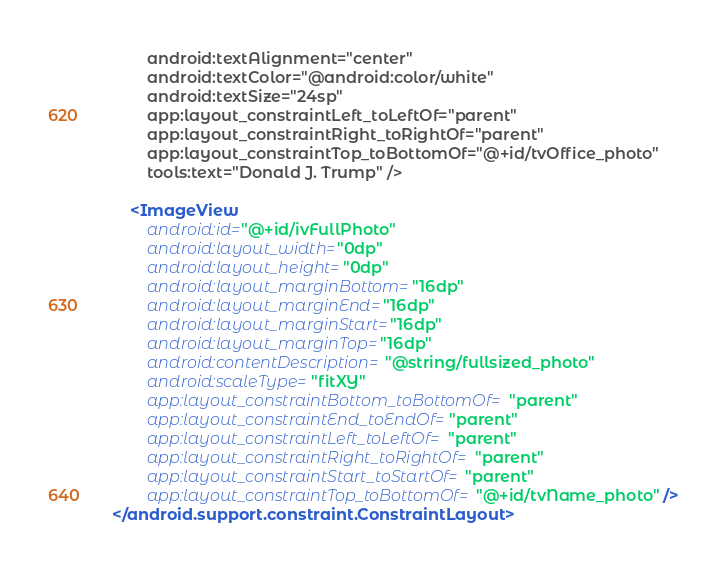Convert code to text. <code><loc_0><loc_0><loc_500><loc_500><_XML_>        android:textAlignment="center"
        android:textColor="@android:color/white"
        android:textSize="24sp"
        app:layout_constraintLeft_toLeftOf="parent"
        app:layout_constraintRight_toRightOf="parent"
        app:layout_constraintTop_toBottomOf="@+id/tvOffice_photo"
        tools:text="Donald J. Trump" />

    <ImageView
        android:id="@+id/ivFullPhoto"
        android:layout_width="0dp"
        android:layout_height="0dp"
        android:layout_marginBottom="16dp"
        android:layout_marginEnd="16dp"
        android:layout_marginStart="16dp"
        android:layout_marginTop="16dp"
        android:contentDescription="@string/fullsized_photo"
        android:scaleType="fitXY"
        app:layout_constraintBottom_toBottomOf="parent"
        app:layout_constraintEnd_toEndOf="parent"
        app:layout_constraintLeft_toLeftOf="parent"
        app:layout_constraintRight_toRightOf="parent"
        app:layout_constraintStart_toStartOf="parent"
        app:layout_constraintTop_toBottomOf="@+id/tvName_photo" />
</android.support.constraint.ConstraintLayout></code> 